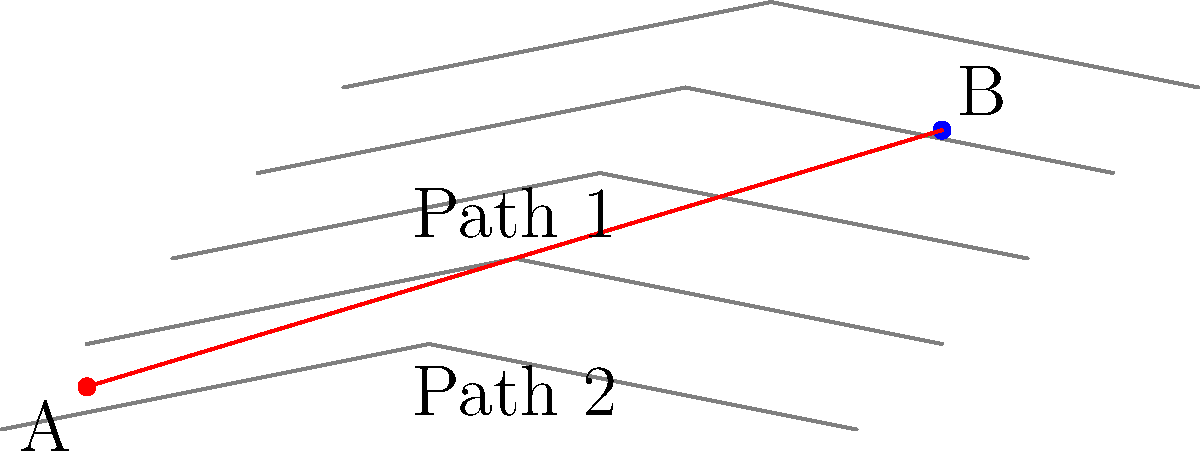Given the topographic map above, which path between points A and B is likely to be the shortest in terms of actual distance traveled on the terrain? Explain your reasoning, considering the contour lines and the principles of least-effort path finding in digital mapping. To determine the shortest path between two points on a topographic map, we need to consider the following factors:

1. Contour lines: These represent equal elevation points. Closely spaced contour lines indicate steeper terrain, while widely spaced lines indicate flatter areas.

2. Straight-line distance: The straight line between two points is the shortest distance in 2D space but may not be the shortest in 3D terrain.

3. Terrain complexity: Moving directly up or down steep slopes often requires more effort and distance than following gentler grades.

4. Path of least resistance: In nature and efficient route planning, the path of least resistance often follows contour lines where possible, making gradual ascents and descents.

Analyzing the given map:

1. Path 1 (red line): This path follows a more gradual ascent, roughly parallel to the contour lines for much of its length. It avoids crossing contour lines at sharp angles, which would indicate steep climbs or descents.

2. Path 2 (green dashed line): This is the straight-line path between A and B. While it appears shorter in 2D, it crosses contour lines at sharper angles, indicating steeper climbs and descents.

In digital mapping and route optimization algorithms (like those used in GPS systems), the path that minimizes the total elevation change while keeping a reasonable horizontal distance is often considered the shortest practical path.

Path 1, although slightly longer in 2D projection, is likely to be shorter in actual traveled distance because:
1. It follows the natural contours of the land more closely.
2. It avoids steep climbs and descents, which would increase the actual distance traveled in 3D space.
3. It represents a more energy-efficient route, which in many path-finding algorithms is equated with the shortest path.

This problem demonstrates the importance of considering 3D terrain in digital mapping technologies, where the shortest path isn't always a straight line.
Answer: Path 1 (the red line) 